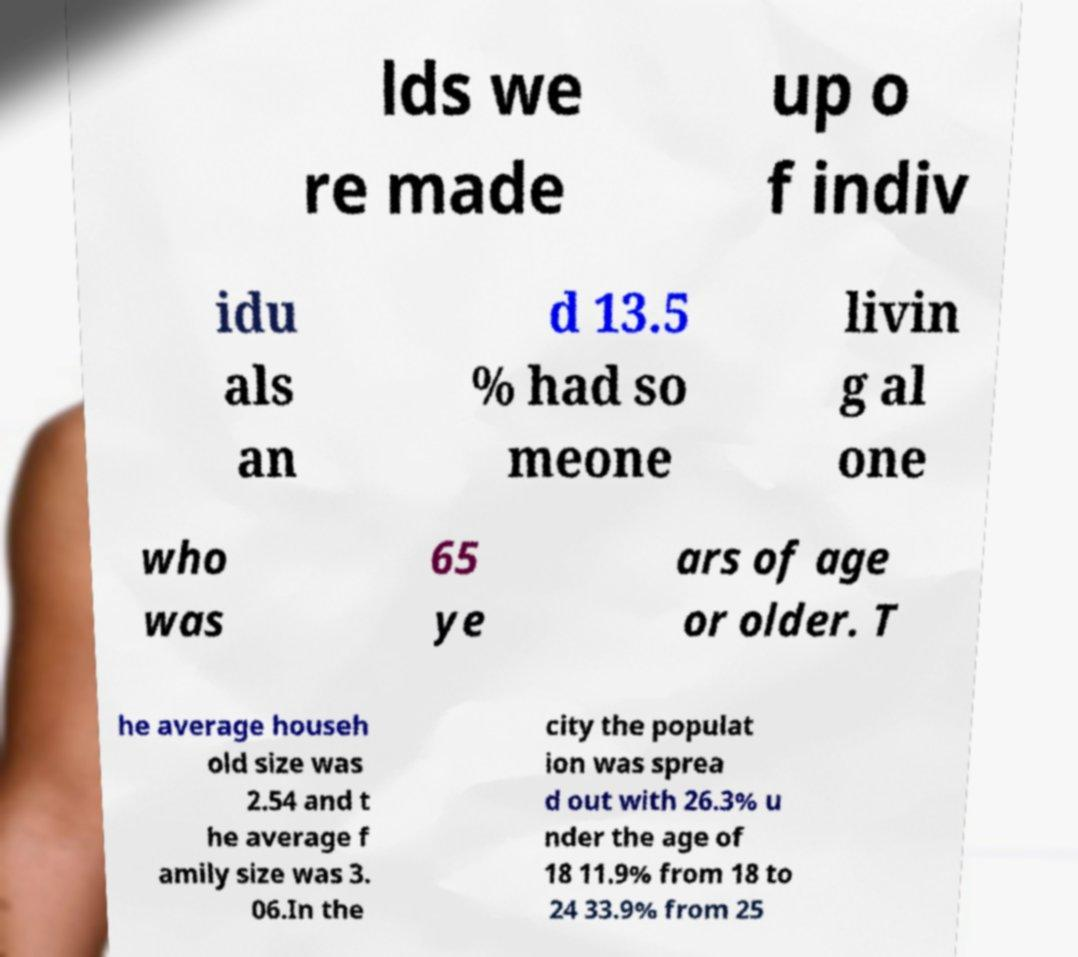Can you read and provide the text displayed in the image?This photo seems to have some interesting text. Can you extract and type it out for me? lds we re made up o f indiv idu als an d 13.5 % had so meone livin g al one who was 65 ye ars of age or older. T he average househ old size was 2.54 and t he average f amily size was 3. 06.In the city the populat ion was sprea d out with 26.3% u nder the age of 18 11.9% from 18 to 24 33.9% from 25 